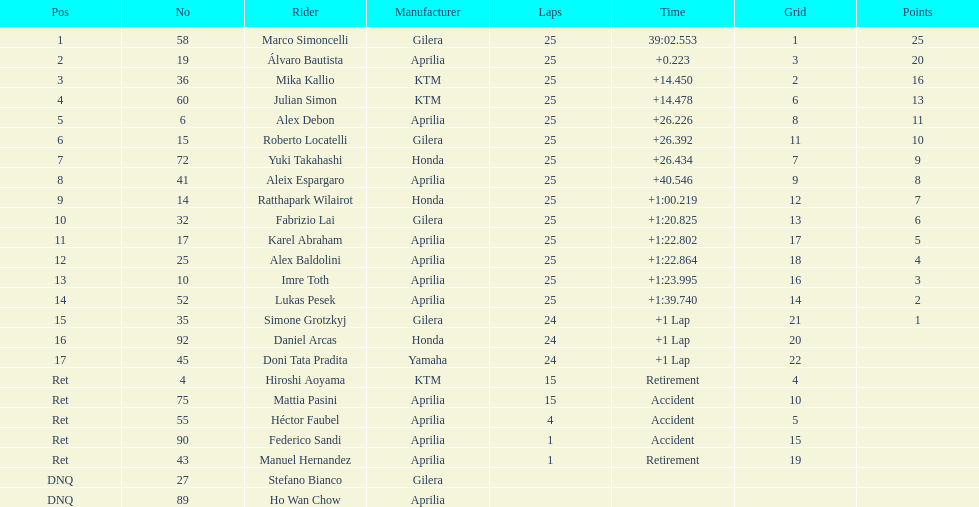Can you give me this table as a dict? {'header': ['Pos', 'No', 'Rider', 'Manufacturer', 'Laps', 'Time', 'Grid', 'Points'], 'rows': [['1', '58', 'Marco Simoncelli', 'Gilera', '25', '39:02.553', '1', '25'], ['2', '19', 'Álvaro Bautista', 'Aprilia', '25', '+0.223', '3', '20'], ['3', '36', 'Mika Kallio', 'KTM', '25', '+14.450', '2', '16'], ['4', '60', 'Julian Simon', 'KTM', '25', '+14.478', '6', '13'], ['5', '6', 'Alex Debon', 'Aprilia', '25', '+26.226', '8', '11'], ['6', '15', 'Roberto Locatelli', 'Gilera', '25', '+26.392', '11', '10'], ['7', '72', 'Yuki Takahashi', 'Honda', '25', '+26.434', '7', '9'], ['8', '41', 'Aleix Espargaro', 'Aprilia', '25', '+40.546', '9', '8'], ['9', '14', 'Ratthapark Wilairot', 'Honda', '25', '+1:00.219', '12', '7'], ['10', '32', 'Fabrizio Lai', 'Gilera', '25', '+1:20.825', '13', '6'], ['11', '17', 'Karel Abraham', 'Aprilia', '25', '+1:22.802', '17', '5'], ['12', '25', 'Alex Baldolini', 'Aprilia', '25', '+1:22.864', '18', '4'], ['13', '10', 'Imre Toth', 'Aprilia', '25', '+1:23.995', '16', '3'], ['14', '52', 'Lukas Pesek', 'Aprilia', '25', '+1:39.740', '14', '2'], ['15', '35', 'Simone Grotzkyj', 'Gilera', '24', '+1 Lap', '21', '1'], ['16', '92', 'Daniel Arcas', 'Honda', '24', '+1 Lap', '20', ''], ['17', '45', 'Doni Tata Pradita', 'Yamaha', '24', '+1 Lap', '22', ''], ['Ret', '4', 'Hiroshi Aoyama', 'KTM', '15', 'Retirement', '4', ''], ['Ret', '75', 'Mattia Pasini', 'Aprilia', '15', 'Accident', '10', ''], ['Ret', '55', 'Héctor Faubel', 'Aprilia', '4', 'Accident', '5', ''], ['Ret', '90', 'Federico Sandi', 'Aprilia', '1', 'Accident', '15', ''], ['Ret', '43', 'Manuel Hernandez', 'Aprilia', '1', 'Retirement', '19', ''], ['DNQ', '27', 'Stefano Bianco', 'Gilera', '', '', '', ''], ['DNQ', '89', 'Ho Wan Chow', 'Aprilia', '', '', '', '']]} Did marco simoncelli or alvaro bautista ever achieve the top ranking? Marco Simoncelli. 